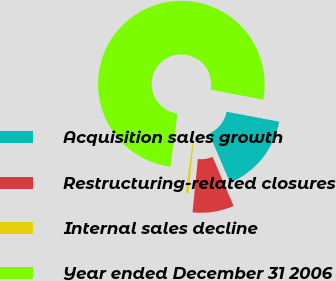Convert chart to OTSL. <chart><loc_0><loc_0><loc_500><loc_500><pie_chart><fcel>Acquisition sales growth<fcel>Restructuring-related closures<fcel>Internal sales decline<fcel>Year ended December 31 2006<nl><fcel>15.58%<fcel>8.04%<fcel>0.51%<fcel>75.87%<nl></chart> 